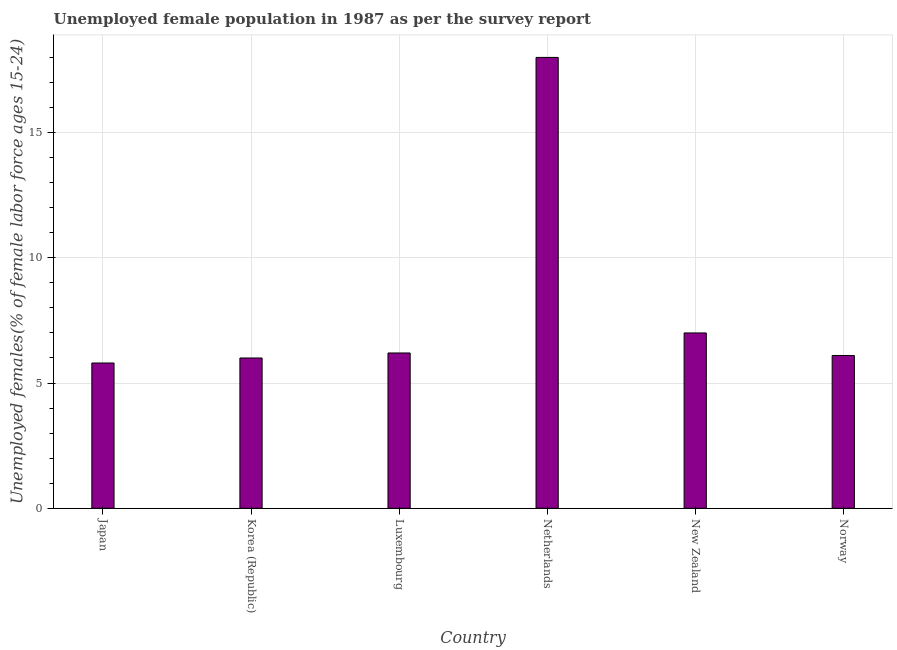Does the graph contain any zero values?
Provide a succinct answer. No. What is the title of the graph?
Give a very brief answer. Unemployed female population in 1987 as per the survey report. What is the label or title of the Y-axis?
Your answer should be very brief. Unemployed females(% of female labor force ages 15-24). What is the unemployed female youth in Japan?
Your answer should be very brief. 5.8. Across all countries, what is the maximum unemployed female youth?
Keep it short and to the point. 18. Across all countries, what is the minimum unemployed female youth?
Provide a succinct answer. 5.8. In which country was the unemployed female youth minimum?
Make the answer very short. Japan. What is the sum of the unemployed female youth?
Make the answer very short. 49.1. What is the difference between the unemployed female youth in New Zealand and Norway?
Offer a very short reply. 0.9. What is the average unemployed female youth per country?
Your answer should be compact. 8.18. What is the median unemployed female youth?
Give a very brief answer. 6.15. In how many countries, is the unemployed female youth greater than 2 %?
Provide a short and direct response. 6. What is the ratio of the unemployed female youth in Netherlands to that in Norway?
Your answer should be compact. 2.95. What is the difference between the highest and the lowest unemployed female youth?
Offer a terse response. 12.2. Are the values on the major ticks of Y-axis written in scientific E-notation?
Make the answer very short. No. What is the Unemployed females(% of female labor force ages 15-24) of Japan?
Keep it short and to the point. 5.8. What is the Unemployed females(% of female labor force ages 15-24) in Korea (Republic)?
Provide a short and direct response. 6. What is the Unemployed females(% of female labor force ages 15-24) in Luxembourg?
Ensure brevity in your answer.  6.2. What is the Unemployed females(% of female labor force ages 15-24) in Netherlands?
Provide a short and direct response. 18. What is the Unemployed females(% of female labor force ages 15-24) in Norway?
Ensure brevity in your answer.  6.1. What is the difference between the Unemployed females(% of female labor force ages 15-24) in Japan and Korea (Republic)?
Provide a succinct answer. -0.2. What is the difference between the Unemployed females(% of female labor force ages 15-24) in Japan and Netherlands?
Provide a short and direct response. -12.2. What is the difference between the Unemployed females(% of female labor force ages 15-24) in Japan and New Zealand?
Your answer should be very brief. -1.2. What is the difference between the Unemployed females(% of female labor force ages 15-24) in Japan and Norway?
Your answer should be compact. -0.3. What is the difference between the Unemployed females(% of female labor force ages 15-24) in Korea (Republic) and Luxembourg?
Provide a succinct answer. -0.2. What is the difference between the Unemployed females(% of female labor force ages 15-24) in Korea (Republic) and Netherlands?
Ensure brevity in your answer.  -12. What is the difference between the Unemployed females(% of female labor force ages 15-24) in Luxembourg and New Zealand?
Keep it short and to the point. -0.8. What is the difference between the Unemployed females(% of female labor force ages 15-24) in Luxembourg and Norway?
Provide a short and direct response. 0.1. What is the difference between the Unemployed females(% of female labor force ages 15-24) in Netherlands and Norway?
Make the answer very short. 11.9. What is the ratio of the Unemployed females(% of female labor force ages 15-24) in Japan to that in Korea (Republic)?
Your response must be concise. 0.97. What is the ratio of the Unemployed females(% of female labor force ages 15-24) in Japan to that in Luxembourg?
Offer a terse response. 0.94. What is the ratio of the Unemployed females(% of female labor force ages 15-24) in Japan to that in Netherlands?
Provide a succinct answer. 0.32. What is the ratio of the Unemployed females(% of female labor force ages 15-24) in Japan to that in New Zealand?
Keep it short and to the point. 0.83. What is the ratio of the Unemployed females(% of female labor force ages 15-24) in Japan to that in Norway?
Offer a very short reply. 0.95. What is the ratio of the Unemployed females(% of female labor force ages 15-24) in Korea (Republic) to that in Luxembourg?
Your answer should be very brief. 0.97. What is the ratio of the Unemployed females(% of female labor force ages 15-24) in Korea (Republic) to that in Netherlands?
Ensure brevity in your answer.  0.33. What is the ratio of the Unemployed females(% of female labor force ages 15-24) in Korea (Republic) to that in New Zealand?
Offer a terse response. 0.86. What is the ratio of the Unemployed females(% of female labor force ages 15-24) in Luxembourg to that in Netherlands?
Keep it short and to the point. 0.34. What is the ratio of the Unemployed females(% of female labor force ages 15-24) in Luxembourg to that in New Zealand?
Give a very brief answer. 0.89. What is the ratio of the Unemployed females(% of female labor force ages 15-24) in Netherlands to that in New Zealand?
Keep it short and to the point. 2.57. What is the ratio of the Unemployed females(% of female labor force ages 15-24) in Netherlands to that in Norway?
Make the answer very short. 2.95. What is the ratio of the Unemployed females(% of female labor force ages 15-24) in New Zealand to that in Norway?
Offer a very short reply. 1.15. 